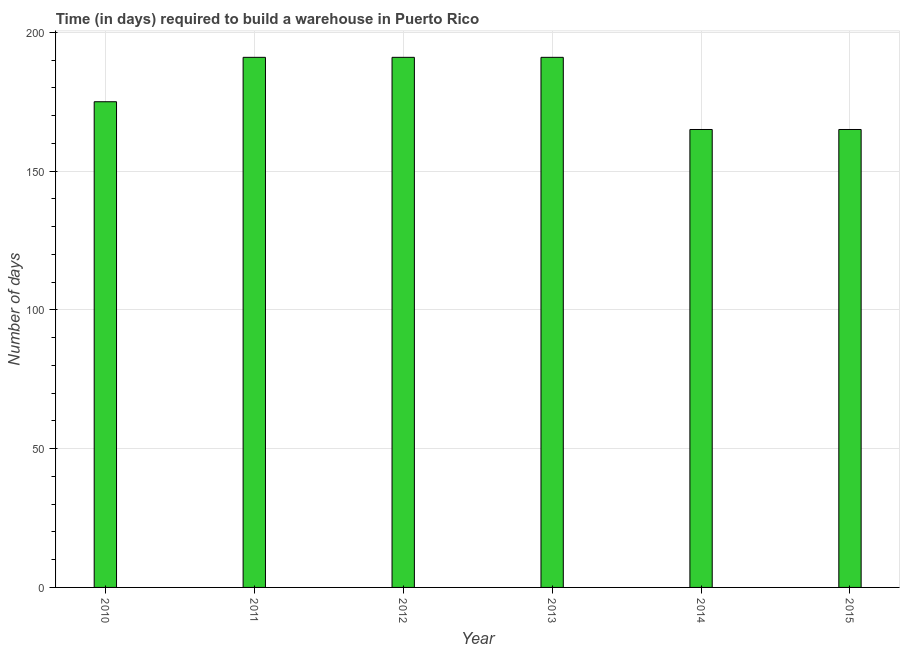Does the graph contain any zero values?
Your answer should be compact. No. What is the title of the graph?
Your response must be concise. Time (in days) required to build a warehouse in Puerto Rico. What is the label or title of the X-axis?
Provide a short and direct response. Year. What is the label or title of the Y-axis?
Offer a terse response. Number of days. What is the time required to build a warehouse in 2010?
Your answer should be compact. 175. Across all years, what is the maximum time required to build a warehouse?
Provide a short and direct response. 191. Across all years, what is the minimum time required to build a warehouse?
Offer a terse response. 165. What is the sum of the time required to build a warehouse?
Provide a short and direct response. 1078. What is the average time required to build a warehouse per year?
Make the answer very short. 179. What is the median time required to build a warehouse?
Offer a very short reply. 183. In how many years, is the time required to build a warehouse greater than 20 days?
Ensure brevity in your answer.  6. Do a majority of the years between 2015 and 2014 (inclusive) have time required to build a warehouse greater than 20 days?
Offer a terse response. No. What is the ratio of the time required to build a warehouse in 2011 to that in 2012?
Make the answer very short. 1. Is the time required to build a warehouse in 2011 less than that in 2013?
Give a very brief answer. No. Is the difference between the time required to build a warehouse in 2010 and 2011 greater than the difference between any two years?
Your answer should be very brief. No. Is the sum of the time required to build a warehouse in 2011 and 2012 greater than the maximum time required to build a warehouse across all years?
Your answer should be very brief. Yes. What is the difference between the highest and the lowest time required to build a warehouse?
Ensure brevity in your answer.  26. In how many years, is the time required to build a warehouse greater than the average time required to build a warehouse taken over all years?
Provide a succinct answer. 3. How many bars are there?
Offer a terse response. 6. Are all the bars in the graph horizontal?
Your response must be concise. No. Are the values on the major ticks of Y-axis written in scientific E-notation?
Your response must be concise. No. What is the Number of days of 2010?
Provide a short and direct response. 175. What is the Number of days of 2011?
Provide a succinct answer. 191. What is the Number of days in 2012?
Offer a terse response. 191. What is the Number of days in 2013?
Your answer should be compact. 191. What is the Number of days of 2014?
Keep it short and to the point. 165. What is the Number of days in 2015?
Provide a short and direct response. 165. What is the difference between the Number of days in 2010 and 2012?
Your answer should be compact. -16. What is the difference between the Number of days in 2010 and 2013?
Provide a succinct answer. -16. What is the difference between the Number of days in 2010 and 2014?
Offer a terse response. 10. What is the difference between the Number of days in 2010 and 2015?
Make the answer very short. 10. What is the difference between the Number of days in 2011 and 2012?
Provide a succinct answer. 0. What is the difference between the Number of days in 2012 and 2013?
Give a very brief answer. 0. What is the difference between the Number of days in 2012 and 2014?
Ensure brevity in your answer.  26. What is the difference between the Number of days in 2012 and 2015?
Your answer should be compact. 26. What is the difference between the Number of days in 2013 and 2015?
Make the answer very short. 26. What is the difference between the Number of days in 2014 and 2015?
Provide a short and direct response. 0. What is the ratio of the Number of days in 2010 to that in 2011?
Keep it short and to the point. 0.92. What is the ratio of the Number of days in 2010 to that in 2012?
Your response must be concise. 0.92. What is the ratio of the Number of days in 2010 to that in 2013?
Your response must be concise. 0.92. What is the ratio of the Number of days in 2010 to that in 2014?
Your answer should be compact. 1.06. What is the ratio of the Number of days in 2010 to that in 2015?
Ensure brevity in your answer.  1.06. What is the ratio of the Number of days in 2011 to that in 2013?
Provide a short and direct response. 1. What is the ratio of the Number of days in 2011 to that in 2014?
Provide a short and direct response. 1.16. What is the ratio of the Number of days in 2011 to that in 2015?
Offer a terse response. 1.16. What is the ratio of the Number of days in 2012 to that in 2013?
Offer a very short reply. 1. What is the ratio of the Number of days in 2012 to that in 2014?
Keep it short and to the point. 1.16. What is the ratio of the Number of days in 2012 to that in 2015?
Your response must be concise. 1.16. What is the ratio of the Number of days in 2013 to that in 2014?
Make the answer very short. 1.16. What is the ratio of the Number of days in 2013 to that in 2015?
Your response must be concise. 1.16. 